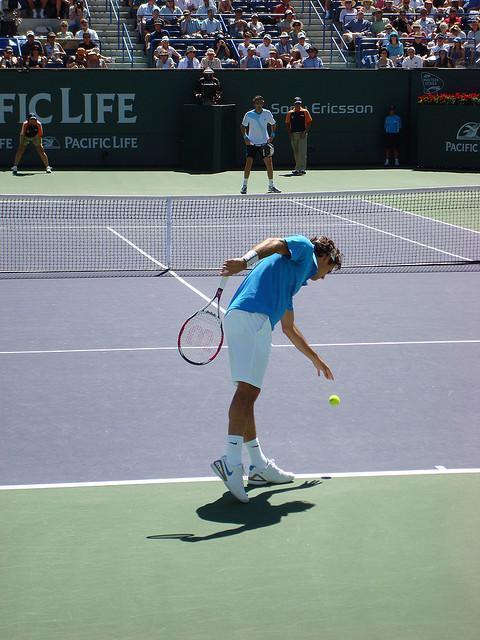How many people are in the picture?
Give a very brief answer. 3. 